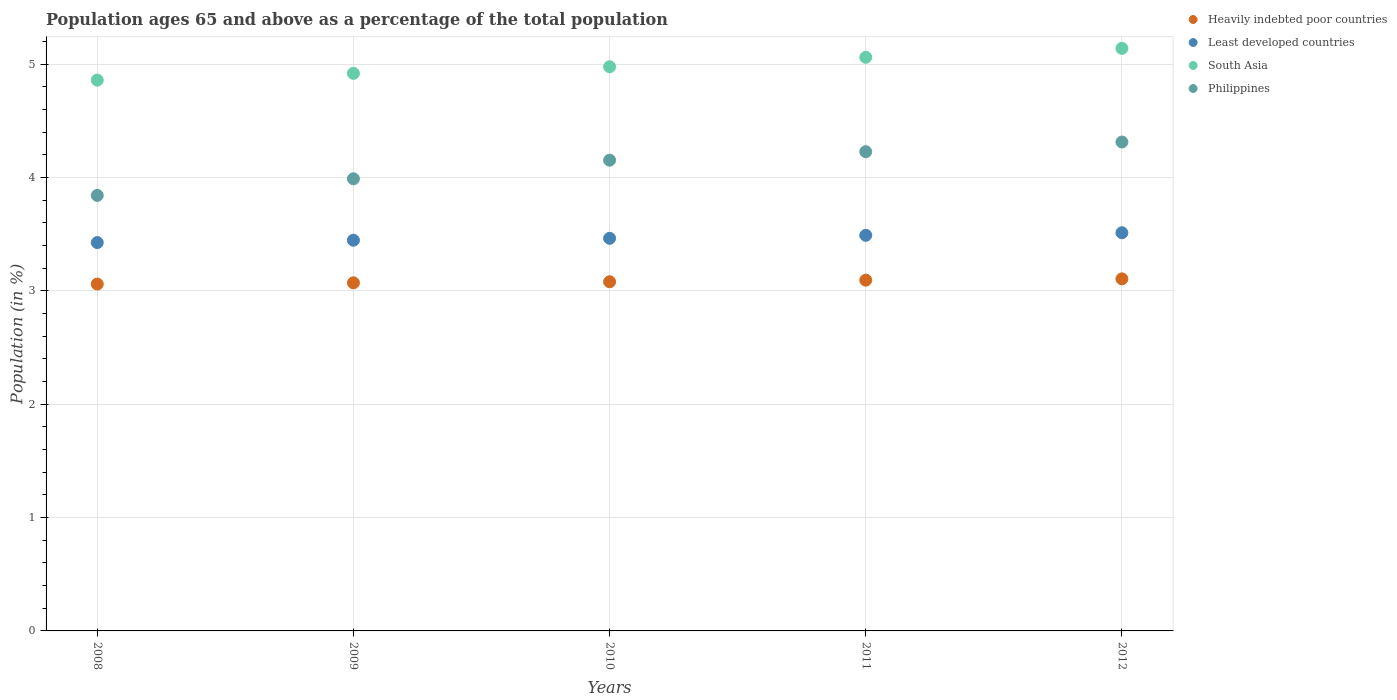What is the percentage of the population ages 65 and above in South Asia in 2010?
Make the answer very short. 4.98. Across all years, what is the maximum percentage of the population ages 65 and above in Heavily indebted poor countries?
Your answer should be very brief. 3.11. Across all years, what is the minimum percentage of the population ages 65 and above in Least developed countries?
Make the answer very short. 3.43. In which year was the percentage of the population ages 65 and above in Least developed countries maximum?
Offer a very short reply. 2012. In which year was the percentage of the population ages 65 and above in Least developed countries minimum?
Give a very brief answer. 2008. What is the total percentage of the population ages 65 and above in South Asia in the graph?
Offer a terse response. 24.96. What is the difference between the percentage of the population ages 65 and above in South Asia in 2010 and that in 2011?
Provide a succinct answer. -0.08. What is the difference between the percentage of the population ages 65 and above in Least developed countries in 2011 and the percentage of the population ages 65 and above in Heavily indebted poor countries in 2008?
Offer a terse response. 0.43. What is the average percentage of the population ages 65 and above in South Asia per year?
Offer a very short reply. 4.99. In the year 2010, what is the difference between the percentage of the population ages 65 and above in Least developed countries and percentage of the population ages 65 and above in South Asia?
Your answer should be very brief. -1.51. What is the ratio of the percentage of the population ages 65 and above in South Asia in 2010 to that in 2011?
Offer a very short reply. 0.98. Is the percentage of the population ages 65 and above in Least developed countries in 2008 less than that in 2012?
Give a very brief answer. Yes. Is the difference between the percentage of the population ages 65 and above in Least developed countries in 2008 and 2010 greater than the difference between the percentage of the population ages 65 and above in South Asia in 2008 and 2010?
Offer a terse response. Yes. What is the difference between the highest and the second highest percentage of the population ages 65 and above in Philippines?
Ensure brevity in your answer.  0.09. What is the difference between the highest and the lowest percentage of the population ages 65 and above in Least developed countries?
Your answer should be compact. 0.09. Does the percentage of the population ages 65 and above in South Asia monotonically increase over the years?
Ensure brevity in your answer.  Yes. Is the percentage of the population ages 65 and above in Heavily indebted poor countries strictly less than the percentage of the population ages 65 and above in Least developed countries over the years?
Keep it short and to the point. Yes. How many dotlines are there?
Your answer should be compact. 4. Are the values on the major ticks of Y-axis written in scientific E-notation?
Give a very brief answer. No. Does the graph contain any zero values?
Make the answer very short. No. Where does the legend appear in the graph?
Offer a very short reply. Top right. How many legend labels are there?
Your response must be concise. 4. What is the title of the graph?
Provide a succinct answer. Population ages 65 and above as a percentage of the total population. What is the label or title of the Y-axis?
Your answer should be very brief. Population (in %). What is the Population (in %) of Heavily indebted poor countries in 2008?
Keep it short and to the point. 3.06. What is the Population (in %) in Least developed countries in 2008?
Your answer should be very brief. 3.43. What is the Population (in %) of South Asia in 2008?
Offer a very short reply. 4.86. What is the Population (in %) in Philippines in 2008?
Give a very brief answer. 3.84. What is the Population (in %) in Heavily indebted poor countries in 2009?
Offer a terse response. 3.07. What is the Population (in %) in Least developed countries in 2009?
Your answer should be compact. 3.45. What is the Population (in %) in South Asia in 2009?
Your answer should be very brief. 4.92. What is the Population (in %) of Philippines in 2009?
Offer a terse response. 3.99. What is the Population (in %) of Heavily indebted poor countries in 2010?
Provide a succinct answer. 3.08. What is the Population (in %) of Least developed countries in 2010?
Ensure brevity in your answer.  3.46. What is the Population (in %) in South Asia in 2010?
Provide a succinct answer. 4.98. What is the Population (in %) of Philippines in 2010?
Give a very brief answer. 4.15. What is the Population (in %) of Heavily indebted poor countries in 2011?
Keep it short and to the point. 3.1. What is the Population (in %) in Least developed countries in 2011?
Your answer should be compact. 3.49. What is the Population (in %) of South Asia in 2011?
Offer a very short reply. 5.06. What is the Population (in %) of Philippines in 2011?
Your answer should be compact. 4.23. What is the Population (in %) in Heavily indebted poor countries in 2012?
Your answer should be very brief. 3.11. What is the Population (in %) in Least developed countries in 2012?
Provide a succinct answer. 3.51. What is the Population (in %) of South Asia in 2012?
Your answer should be very brief. 5.14. What is the Population (in %) of Philippines in 2012?
Ensure brevity in your answer.  4.31. Across all years, what is the maximum Population (in %) in Heavily indebted poor countries?
Make the answer very short. 3.11. Across all years, what is the maximum Population (in %) of Least developed countries?
Make the answer very short. 3.51. Across all years, what is the maximum Population (in %) of South Asia?
Your response must be concise. 5.14. Across all years, what is the maximum Population (in %) of Philippines?
Offer a very short reply. 4.31. Across all years, what is the minimum Population (in %) in Heavily indebted poor countries?
Your answer should be very brief. 3.06. Across all years, what is the minimum Population (in %) of Least developed countries?
Offer a terse response. 3.43. Across all years, what is the minimum Population (in %) in South Asia?
Provide a succinct answer. 4.86. Across all years, what is the minimum Population (in %) of Philippines?
Your answer should be compact. 3.84. What is the total Population (in %) of Heavily indebted poor countries in the graph?
Provide a short and direct response. 15.42. What is the total Population (in %) of Least developed countries in the graph?
Provide a short and direct response. 17.34. What is the total Population (in %) in South Asia in the graph?
Your response must be concise. 24.96. What is the total Population (in %) in Philippines in the graph?
Provide a succinct answer. 20.53. What is the difference between the Population (in %) of Heavily indebted poor countries in 2008 and that in 2009?
Offer a very short reply. -0.01. What is the difference between the Population (in %) of Least developed countries in 2008 and that in 2009?
Your answer should be compact. -0.02. What is the difference between the Population (in %) in South Asia in 2008 and that in 2009?
Your answer should be compact. -0.06. What is the difference between the Population (in %) in Philippines in 2008 and that in 2009?
Your answer should be very brief. -0.15. What is the difference between the Population (in %) of Heavily indebted poor countries in 2008 and that in 2010?
Offer a terse response. -0.02. What is the difference between the Population (in %) in Least developed countries in 2008 and that in 2010?
Your answer should be compact. -0.04. What is the difference between the Population (in %) of South Asia in 2008 and that in 2010?
Give a very brief answer. -0.12. What is the difference between the Population (in %) in Philippines in 2008 and that in 2010?
Offer a terse response. -0.31. What is the difference between the Population (in %) in Heavily indebted poor countries in 2008 and that in 2011?
Make the answer very short. -0.03. What is the difference between the Population (in %) in Least developed countries in 2008 and that in 2011?
Keep it short and to the point. -0.06. What is the difference between the Population (in %) in South Asia in 2008 and that in 2011?
Your answer should be compact. -0.2. What is the difference between the Population (in %) in Philippines in 2008 and that in 2011?
Offer a terse response. -0.39. What is the difference between the Population (in %) of Heavily indebted poor countries in 2008 and that in 2012?
Your answer should be compact. -0.05. What is the difference between the Population (in %) in Least developed countries in 2008 and that in 2012?
Provide a succinct answer. -0.09. What is the difference between the Population (in %) of South Asia in 2008 and that in 2012?
Ensure brevity in your answer.  -0.28. What is the difference between the Population (in %) of Philippines in 2008 and that in 2012?
Your response must be concise. -0.47. What is the difference between the Population (in %) of Heavily indebted poor countries in 2009 and that in 2010?
Offer a very short reply. -0.01. What is the difference between the Population (in %) of Least developed countries in 2009 and that in 2010?
Offer a terse response. -0.02. What is the difference between the Population (in %) of South Asia in 2009 and that in 2010?
Your response must be concise. -0.06. What is the difference between the Population (in %) in Philippines in 2009 and that in 2010?
Offer a very short reply. -0.16. What is the difference between the Population (in %) of Heavily indebted poor countries in 2009 and that in 2011?
Provide a succinct answer. -0.02. What is the difference between the Population (in %) in Least developed countries in 2009 and that in 2011?
Give a very brief answer. -0.04. What is the difference between the Population (in %) in South Asia in 2009 and that in 2011?
Your response must be concise. -0.14. What is the difference between the Population (in %) in Philippines in 2009 and that in 2011?
Your answer should be compact. -0.24. What is the difference between the Population (in %) in Heavily indebted poor countries in 2009 and that in 2012?
Your answer should be very brief. -0.03. What is the difference between the Population (in %) of Least developed countries in 2009 and that in 2012?
Provide a succinct answer. -0.07. What is the difference between the Population (in %) of South Asia in 2009 and that in 2012?
Provide a short and direct response. -0.22. What is the difference between the Population (in %) in Philippines in 2009 and that in 2012?
Make the answer very short. -0.32. What is the difference between the Population (in %) in Heavily indebted poor countries in 2010 and that in 2011?
Keep it short and to the point. -0.01. What is the difference between the Population (in %) of Least developed countries in 2010 and that in 2011?
Offer a very short reply. -0.03. What is the difference between the Population (in %) of South Asia in 2010 and that in 2011?
Offer a very short reply. -0.08. What is the difference between the Population (in %) in Philippines in 2010 and that in 2011?
Provide a succinct answer. -0.07. What is the difference between the Population (in %) of Heavily indebted poor countries in 2010 and that in 2012?
Your answer should be very brief. -0.03. What is the difference between the Population (in %) of Least developed countries in 2010 and that in 2012?
Offer a very short reply. -0.05. What is the difference between the Population (in %) of South Asia in 2010 and that in 2012?
Offer a very short reply. -0.16. What is the difference between the Population (in %) in Philippines in 2010 and that in 2012?
Provide a short and direct response. -0.16. What is the difference between the Population (in %) in Heavily indebted poor countries in 2011 and that in 2012?
Your answer should be compact. -0.01. What is the difference between the Population (in %) in Least developed countries in 2011 and that in 2012?
Your answer should be compact. -0.02. What is the difference between the Population (in %) in South Asia in 2011 and that in 2012?
Your response must be concise. -0.08. What is the difference between the Population (in %) in Philippines in 2011 and that in 2012?
Ensure brevity in your answer.  -0.09. What is the difference between the Population (in %) of Heavily indebted poor countries in 2008 and the Population (in %) of Least developed countries in 2009?
Offer a very short reply. -0.39. What is the difference between the Population (in %) in Heavily indebted poor countries in 2008 and the Population (in %) in South Asia in 2009?
Keep it short and to the point. -1.86. What is the difference between the Population (in %) in Heavily indebted poor countries in 2008 and the Population (in %) in Philippines in 2009?
Provide a short and direct response. -0.93. What is the difference between the Population (in %) of Least developed countries in 2008 and the Population (in %) of South Asia in 2009?
Give a very brief answer. -1.49. What is the difference between the Population (in %) of Least developed countries in 2008 and the Population (in %) of Philippines in 2009?
Your response must be concise. -0.56. What is the difference between the Population (in %) in South Asia in 2008 and the Population (in %) in Philippines in 2009?
Provide a short and direct response. 0.87. What is the difference between the Population (in %) of Heavily indebted poor countries in 2008 and the Population (in %) of Least developed countries in 2010?
Ensure brevity in your answer.  -0.4. What is the difference between the Population (in %) of Heavily indebted poor countries in 2008 and the Population (in %) of South Asia in 2010?
Offer a terse response. -1.92. What is the difference between the Population (in %) of Heavily indebted poor countries in 2008 and the Population (in %) of Philippines in 2010?
Your response must be concise. -1.09. What is the difference between the Population (in %) of Least developed countries in 2008 and the Population (in %) of South Asia in 2010?
Keep it short and to the point. -1.55. What is the difference between the Population (in %) of Least developed countries in 2008 and the Population (in %) of Philippines in 2010?
Ensure brevity in your answer.  -0.73. What is the difference between the Population (in %) in South Asia in 2008 and the Population (in %) in Philippines in 2010?
Provide a succinct answer. 0.71. What is the difference between the Population (in %) in Heavily indebted poor countries in 2008 and the Population (in %) in Least developed countries in 2011?
Make the answer very short. -0.43. What is the difference between the Population (in %) of Heavily indebted poor countries in 2008 and the Population (in %) of South Asia in 2011?
Offer a terse response. -2. What is the difference between the Population (in %) of Heavily indebted poor countries in 2008 and the Population (in %) of Philippines in 2011?
Keep it short and to the point. -1.17. What is the difference between the Population (in %) of Least developed countries in 2008 and the Population (in %) of South Asia in 2011?
Offer a terse response. -1.64. What is the difference between the Population (in %) in Least developed countries in 2008 and the Population (in %) in Philippines in 2011?
Offer a very short reply. -0.8. What is the difference between the Population (in %) in South Asia in 2008 and the Population (in %) in Philippines in 2011?
Give a very brief answer. 0.63. What is the difference between the Population (in %) of Heavily indebted poor countries in 2008 and the Population (in %) of Least developed countries in 2012?
Your answer should be very brief. -0.45. What is the difference between the Population (in %) of Heavily indebted poor countries in 2008 and the Population (in %) of South Asia in 2012?
Ensure brevity in your answer.  -2.08. What is the difference between the Population (in %) of Heavily indebted poor countries in 2008 and the Population (in %) of Philippines in 2012?
Your answer should be compact. -1.25. What is the difference between the Population (in %) of Least developed countries in 2008 and the Population (in %) of South Asia in 2012?
Provide a short and direct response. -1.71. What is the difference between the Population (in %) of Least developed countries in 2008 and the Population (in %) of Philippines in 2012?
Your answer should be very brief. -0.89. What is the difference between the Population (in %) of South Asia in 2008 and the Population (in %) of Philippines in 2012?
Offer a very short reply. 0.55. What is the difference between the Population (in %) of Heavily indebted poor countries in 2009 and the Population (in %) of Least developed countries in 2010?
Your answer should be compact. -0.39. What is the difference between the Population (in %) of Heavily indebted poor countries in 2009 and the Population (in %) of South Asia in 2010?
Give a very brief answer. -1.91. What is the difference between the Population (in %) of Heavily indebted poor countries in 2009 and the Population (in %) of Philippines in 2010?
Offer a terse response. -1.08. What is the difference between the Population (in %) of Least developed countries in 2009 and the Population (in %) of South Asia in 2010?
Keep it short and to the point. -1.53. What is the difference between the Population (in %) of Least developed countries in 2009 and the Population (in %) of Philippines in 2010?
Your answer should be very brief. -0.71. What is the difference between the Population (in %) of South Asia in 2009 and the Population (in %) of Philippines in 2010?
Offer a terse response. 0.77. What is the difference between the Population (in %) in Heavily indebted poor countries in 2009 and the Population (in %) in Least developed countries in 2011?
Give a very brief answer. -0.42. What is the difference between the Population (in %) in Heavily indebted poor countries in 2009 and the Population (in %) in South Asia in 2011?
Your answer should be very brief. -1.99. What is the difference between the Population (in %) in Heavily indebted poor countries in 2009 and the Population (in %) in Philippines in 2011?
Offer a very short reply. -1.16. What is the difference between the Population (in %) of Least developed countries in 2009 and the Population (in %) of South Asia in 2011?
Provide a short and direct response. -1.61. What is the difference between the Population (in %) in Least developed countries in 2009 and the Population (in %) in Philippines in 2011?
Give a very brief answer. -0.78. What is the difference between the Population (in %) in South Asia in 2009 and the Population (in %) in Philippines in 2011?
Offer a very short reply. 0.69. What is the difference between the Population (in %) of Heavily indebted poor countries in 2009 and the Population (in %) of Least developed countries in 2012?
Offer a very short reply. -0.44. What is the difference between the Population (in %) in Heavily indebted poor countries in 2009 and the Population (in %) in South Asia in 2012?
Your answer should be very brief. -2.07. What is the difference between the Population (in %) in Heavily indebted poor countries in 2009 and the Population (in %) in Philippines in 2012?
Provide a short and direct response. -1.24. What is the difference between the Population (in %) of Least developed countries in 2009 and the Population (in %) of South Asia in 2012?
Your answer should be very brief. -1.69. What is the difference between the Population (in %) in Least developed countries in 2009 and the Population (in %) in Philippines in 2012?
Make the answer very short. -0.87. What is the difference between the Population (in %) of South Asia in 2009 and the Population (in %) of Philippines in 2012?
Provide a short and direct response. 0.61. What is the difference between the Population (in %) of Heavily indebted poor countries in 2010 and the Population (in %) of Least developed countries in 2011?
Offer a very short reply. -0.41. What is the difference between the Population (in %) of Heavily indebted poor countries in 2010 and the Population (in %) of South Asia in 2011?
Give a very brief answer. -1.98. What is the difference between the Population (in %) in Heavily indebted poor countries in 2010 and the Population (in %) in Philippines in 2011?
Offer a very short reply. -1.15. What is the difference between the Population (in %) in Least developed countries in 2010 and the Population (in %) in South Asia in 2011?
Make the answer very short. -1.6. What is the difference between the Population (in %) in Least developed countries in 2010 and the Population (in %) in Philippines in 2011?
Your answer should be very brief. -0.76. What is the difference between the Population (in %) in South Asia in 2010 and the Population (in %) in Philippines in 2011?
Ensure brevity in your answer.  0.75. What is the difference between the Population (in %) in Heavily indebted poor countries in 2010 and the Population (in %) in Least developed countries in 2012?
Your answer should be compact. -0.43. What is the difference between the Population (in %) of Heavily indebted poor countries in 2010 and the Population (in %) of South Asia in 2012?
Offer a terse response. -2.06. What is the difference between the Population (in %) of Heavily indebted poor countries in 2010 and the Population (in %) of Philippines in 2012?
Provide a short and direct response. -1.23. What is the difference between the Population (in %) in Least developed countries in 2010 and the Population (in %) in South Asia in 2012?
Offer a very short reply. -1.68. What is the difference between the Population (in %) of Least developed countries in 2010 and the Population (in %) of Philippines in 2012?
Provide a succinct answer. -0.85. What is the difference between the Population (in %) of South Asia in 2010 and the Population (in %) of Philippines in 2012?
Make the answer very short. 0.66. What is the difference between the Population (in %) of Heavily indebted poor countries in 2011 and the Population (in %) of Least developed countries in 2012?
Keep it short and to the point. -0.42. What is the difference between the Population (in %) in Heavily indebted poor countries in 2011 and the Population (in %) in South Asia in 2012?
Give a very brief answer. -2.05. What is the difference between the Population (in %) in Heavily indebted poor countries in 2011 and the Population (in %) in Philippines in 2012?
Your answer should be very brief. -1.22. What is the difference between the Population (in %) in Least developed countries in 2011 and the Population (in %) in South Asia in 2012?
Ensure brevity in your answer.  -1.65. What is the difference between the Population (in %) in Least developed countries in 2011 and the Population (in %) in Philippines in 2012?
Give a very brief answer. -0.82. What is the difference between the Population (in %) of South Asia in 2011 and the Population (in %) of Philippines in 2012?
Offer a terse response. 0.75. What is the average Population (in %) of Heavily indebted poor countries per year?
Provide a succinct answer. 3.08. What is the average Population (in %) in Least developed countries per year?
Your answer should be compact. 3.47. What is the average Population (in %) in South Asia per year?
Make the answer very short. 4.99. What is the average Population (in %) in Philippines per year?
Offer a very short reply. 4.11. In the year 2008, what is the difference between the Population (in %) of Heavily indebted poor countries and Population (in %) of Least developed countries?
Provide a short and direct response. -0.37. In the year 2008, what is the difference between the Population (in %) in Heavily indebted poor countries and Population (in %) in South Asia?
Ensure brevity in your answer.  -1.8. In the year 2008, what is the difference between the Population (in %) of Heavily indebted poor countries and Population (in %) of Philippines?
Your response must be concise. -0.78. In the year 2008, what is the difference between the Population (in %) in Least developed countries and Population (in %) in South Asia?
Provide a succinct answer. -1.43. In the year 2008, what is the difference between the Population (in %) in Least developed countries and Population (in %) in Philippines?
Give a very brief answer. -0.42. In the year 2008, what is the difference between the Population (in %) in South Asia and Population (in %) in Philippines?
Your answer should be very brief. 1.02. In the year 2009, what is the difference between the Population (in %) in Heavily indebted poor countries and Population (in %) in Least developed countries?
Ensure brevity in your answer.  -0.38. In the year 2009, what is the difference between the Population (in %) of Heavily indebted poor countries and Population (in %) of South Asia?
Provide a succinct answer. -1.85. In the year 2009, what is the difference between the Population (in %) of Heavily indebted poor countries and Population (in %) of Philippines?
Ensure brevity in your answer.  -0.92. In the year 2009, what is the difference between the Population (in %) in Least developed countries and Population (in %) in South Asia?
Provide a short and direct response. -1.47. In the year 2009, what is the difference between the Population (in %) of Least developed countries and Population (in %) of Philippines?
Offer a very short reply. -0.54. In the year 2009, what is the difference between the Population (in %) of South Asia and Population (in %) of Philippines?
Give a very brief answer. 0.93. In the year 2010, what is the difference between the Population (in %) of Heavily indebted poor countries and Population (in %) of Least developed countries?
Provide a short and direct response. -0.38. In the year 2010, what is the difference between the Population (in %) of Heavily indebted poor countries and Population (in %) of South Asia?
Give a very brief answer. -1.9. In the year 2010, what is the difference between the Population (in %) in Heavily indebted poor countries and Population (in %) in Philippines?
Provide a succinct answer. -1.07. In the year 2010, what is the difference between the Population (in %) of Least developed countries and Population (in %) of South Asia?
Make the answer very short. -1.51. In the year 2010, what is the difference between the Population (in %) of Least developed countries and Population (in %) of Philippines?
Offer a very short reply. -0.69. In the year 2010, what is the difference between the Population (in %) in South Asia and Population (in %) in Philippines?
Ensure brevity in your answer.  0.82. In the year 2011, what is the difference between the Population (in %) in Heavily indebted poor countries and Population (in %) in Least developed countries?
Make the answer very short. -0.4. In the year 2011, what is the difference between the Population (in %) in Heavily indebted poor countries and Population (in %) in South Asia?
Keep it short and to the point. -1.97. In the year 2011, what is the difference between the Population (in %) of Heavily indebted poor countries and Population (in %) of Philippines?
Your answer should be compact. -1.13. In the year 2011, what is the difference between the Population (in %) in Least developed countries and Population (in %) in South Asia?
Make the answer very short. -1.57. In the year 2011, what is the difference between the Population (in %) in Least developed countries and Population (in %) in Philippines?
Ensure brevity in your answer.  -0.74. In the year 2011, what is the difference between the Population (in %) in South Asia and Population (in %) in Philippines?
Your answer should be compact. 0.83. In the year 2012, what is the difference between the Population (in %) of Heavily indebted poor countries and Population (in %) of Least developed countries?
Offer a terse response. -0.41. In the year 2012, what is the difference between the Population (in %) in Heavily indebted poor countries and Population (in %) in South Asia?
Keep it short and to the point. -2.03. In the year 2012, what is the difference between the Population (in %) of Heavily indebted poor countries and Population (in %) of Philippines?
Give a very brief answer. -1.21. In the year 2012, what is the difference between the Population (in %) of Least developed countries and Population (in %) of South Asia?
Your answer should be very brief. -1.63. In the year 2012, what is the difference between the Population (in %) in Least developed countries and Population (in %) in Philippines?
Make the answer very short. -0.8. In the year 2012, what is the difference between the Population (in %) in South Asia and Population (in %) in Philippines?
Make the answer very short. 0.83. What is the ratio of the Population (in %) of Heavily indebted poor countries in 2008 to that in 2009?
Make the answer very short. 1. What is the ratio of the Population (in %) of South Asia in 2008 to that in 2009?
Provide a succinct answer. 0.99. What is the ratio of the Population (in %) of Philippines in 2008 to that in 2009?
Ensure brevity in your answer.  0.96. What is the ratio of the Population (in %) of Least developed countries in 2008 to that in 2010?
Provide a succinct answer. 0.99. What is the ratio of the Population (in %) of South Asia in 2008 to that in 2010?
Your answer should be very brief. 0.98. What is the ratio of the Population (in %) of Philippines in 2008 to that in 2010?
Keep it short and to the point. 0.93. What is the ratio of the Population (in %) of Heavily indebted poor countries in 2008 to that in 2011?
Ensure brevity in your answer.  0.99. What is the ratio of the Population (in %) of Least developed countries in 2008 to that in 2011?
Your answer should be compact. 0.98. What is the ratio of the Population (in %) in South Asia in 2008 to that in 2011?
Offer a very short reply. 0.96. What is the ratio of the Population (in %) in Philippines in 2008 to that in 2011?
Keep it short and to the point. 0.91. What is the ratio of the Population (in %) in Heavily indebted poor countries in 2008 to that in 2012?
Your response must be concise. 0.99. What is the ratio of the Population (in %) of Least developed countries in 2008 to that in 2012?
Keep it short and to the point. 0.98. What is the ratio of the Population (in %) of South Asia in 2008 to that in 2012?
Your answer should be compact. 0.95. What is the ratio of the Population (in %) in Philippines in 2008 to that in 2012?
Your answer should be compact. 0.89. What is the ratio of the Population (in %) in South Asia in 2009 to that in 2010?
Provide a succinct answer. 0.99. What is the ratio of the Population (in %) of Philippines in 2009 to that in 2010?
Offer a very short reply. 0.96. What is the ratio of the Population (in %) in Heavily indebted poor countries in 2009 to that in 2011?
Make the answer very short. 0.99. What is the ratio of the Population (in %) in Least developed countries in 2009 to that in 2011?
Provide a short and direct response. 0.99. What is the ratio of the Population (in %) of Philippines in 2009 to that in 2011?
Provide a short and direct response. 0.94. What is the ratio of the Population (in %) of Heavily indebted poor countries in 2009 to that in 2012?
Your answer should be very brief. 0.99. What is the ratio of the Population (in %) in Least developed countries in 2009 to that in 2012?
Ensure brevity in your answer.  0.98. What is the ratio of the Population (in %) of South Asia in 2009 to that in 2012?
Ensure brevity in your answer.  0.96. What is the ratio of the Population (in %) in Philippines in 2009 to that in 2012?
Ensure brevity in your answer.  0.92. What is the ratio of the Population (in %) in Heavily indebted poor countries in 2010 to that in 2011?
Keep it short and to the point. 1. What is the ratio of the Population (in %) of Least developed countries in 2010 to that in 2011?
Make the answer very short. 0.99. What is the ratio of the Population (in %) of South Asia in 2010 to that in 2011?
Provide a succinct answer. 0.98. What is the ratio of the Population (in %) of Philippines in 2010 to that in 2011?
Ensure brevity in your answer.  0.98. What is the ratio of the Population (in %) in Heavily indebted poor countries in 2010 to that in 2012?
Keep it short and to the point. 0.99. What is the ratio of the Population (in %) in Least developed countries in 2010 to that in 2012?
Keep it short and to the point. 0.99. What is the ratio of the Population (in %) in South Asia in 2010 to that in 2012?
Your answer should be compact. 0.97. What is the ratio of the Population (in %) of Philippines in 2010 to that in 2012?
Offer a very short reply. 0.96. What is the ratio of the Population (in %) in South Asia in 2011 to that in 2012?
Your answer should be compact. 0.98. What is the ratio of the Population (in %) in Philippines in 2011 to that in 2012?
Your answer should be very brief. 0.98. What is the difference between the highest and the second highest Population (in %) in Heavily indebted poor countries?
Your answer should be compact. 0.01. What is the difference between the highest and the second highest Population (in %) in Least developed countries?
Offer a terse response. 0.02. What is the difference between the highest and the second highest Population (in %) in South Asia?
Provide a short and direct response. 0.08. What is the difference between the highest and the second highest Population (in %) in Philippines?
Offer a terse response. 0.09. What is the difference between the highest and the lowest Population (in %) in Heavily indebted poor countries?
Give a very brief answer. 0.05. What is the difference between the highest and the lowest Population (in %) of Least developed countries?
Provide a short and direct response. 0.09. What is the difference between the highest and the lowest Population (in %) in South Asia?
Provide a short and direct response. 0.28. What is the difference between the highest and the lowest Population (in %) in Philippines?
Provide a succinct answer. 0.47. 